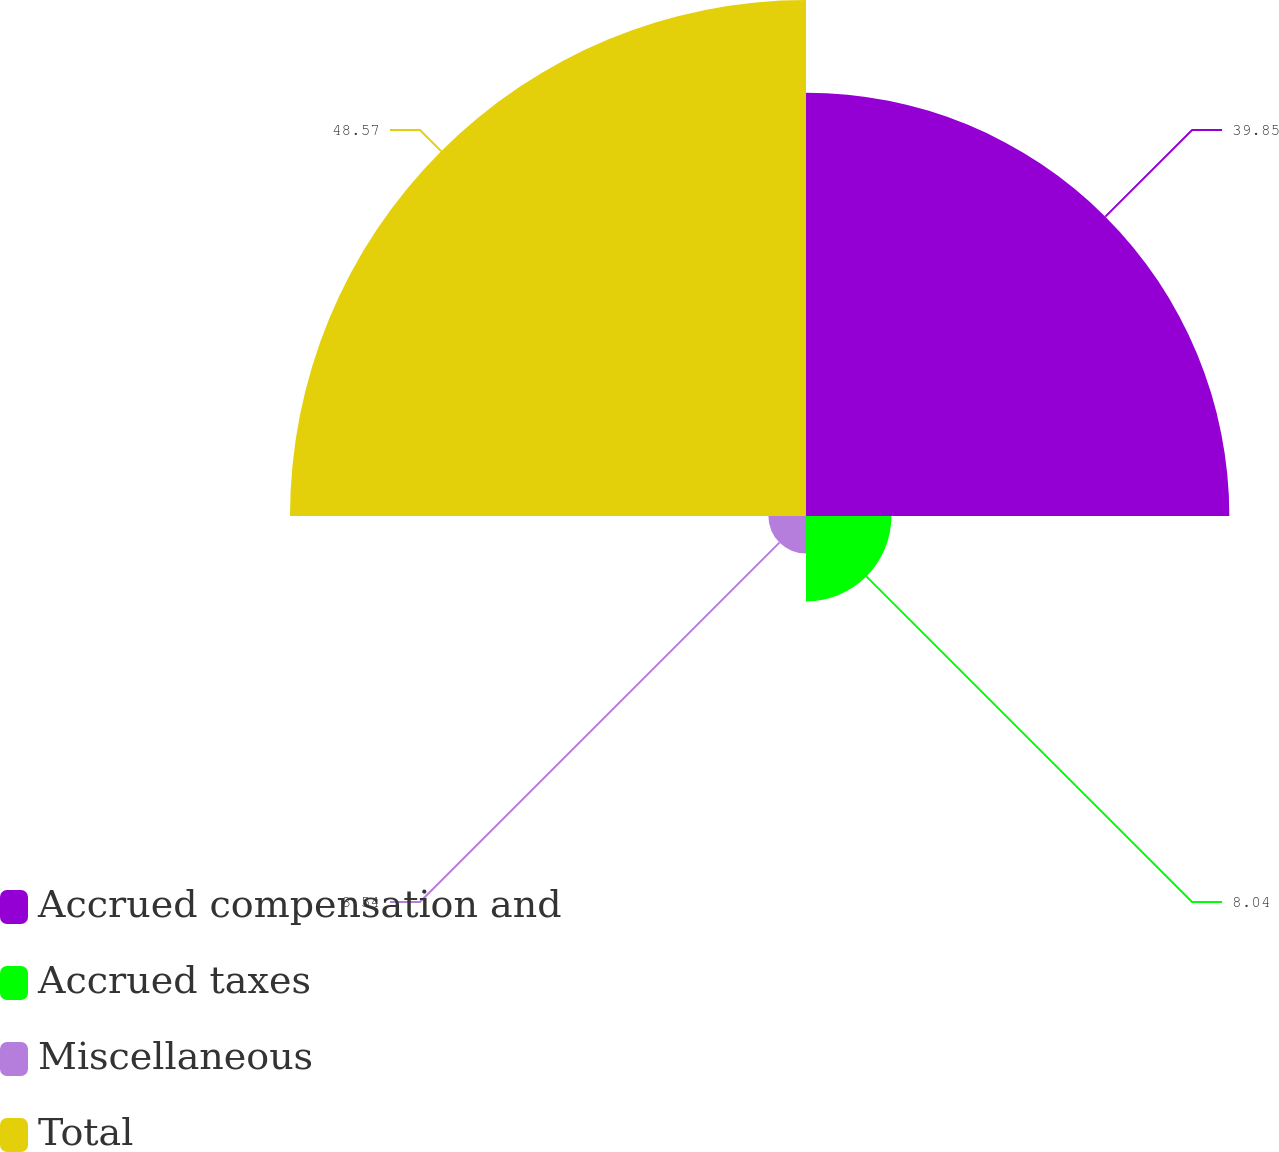Convert chart to OTSL. <chart><loc_0><loc_0><loc_500><loc_500><pie_chart><fcel>Accrued compensation and<fcel>Accrued taxes<fcel>Miscellaneous<fcel>Total<nl><fcel>39.85%<fcel>8.04%<fcel>3.54%<fcel>48.57%<nl></chart> 